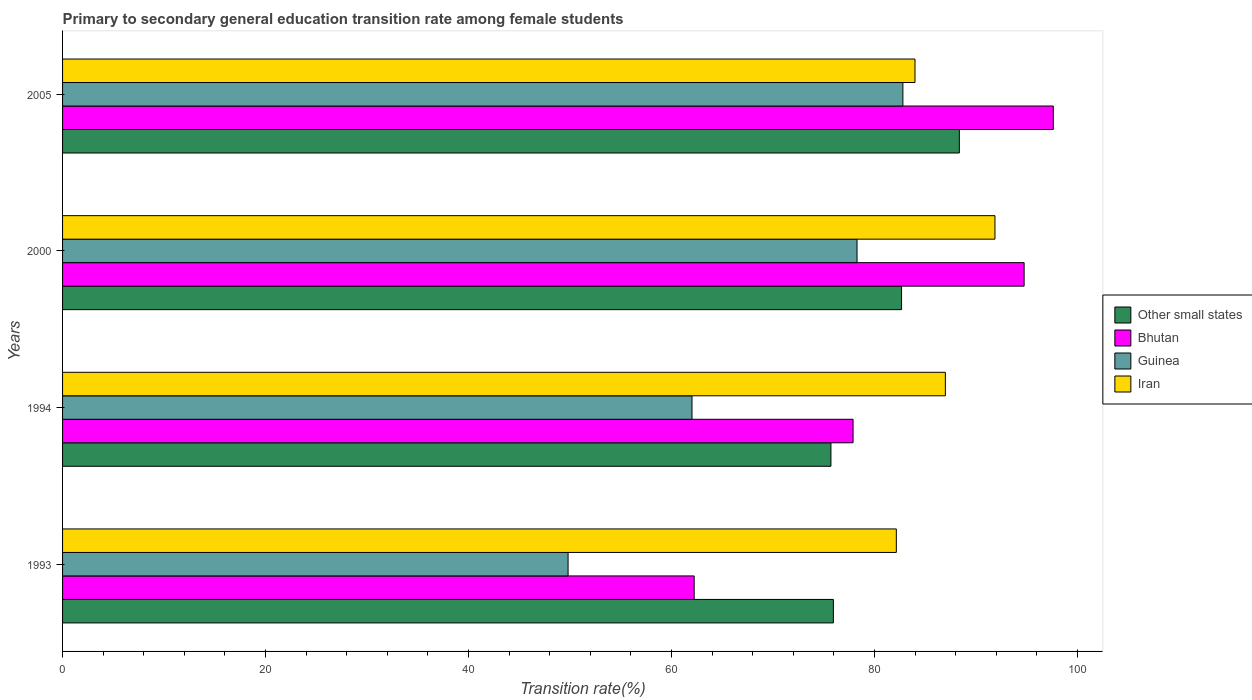How many groups of bars are there?
Ensure brevity in your answer.  4. Are the number of bars per tick equal to the number of legend labels?
Offer a terse response. Yes. How many bars are there on the 3rd tick from the top?
Your answer should be very brief. 4. How many bars are there on the 2nd tick from the bottom?
Your response must be concise. 4. What is the transition rate in Bhutan in 1994?
Provide a succinct answer. 77.89. Across all years, what is the maximum transition rate in Other small states?
Keep it short and to the point. 88.36. Across all years, what is the minimum transition rate in Guinea?
Ensure brevity in your answer.  49.81. In which year was the transition rate in Other small states maximum?
Make the answer very short. 2005. What is the total transition rate in Guinea in the graph?
Offer a terse response. 272.91. What is the difference between the transition rate in Iran in 1994 and that in 2000?
Offer a terse response. -4.89. What is the difference between the transition rate in Guinea in 1994 and the transition rate in Iran in 2005?
Provide a short and direct response. -21.97. What is the average transition rate in Other small states per year?
Offer a very short reply. 80.67. In the year 1994, what is the difference between the transition rate in Other small states and transition rate in Iran?
Keep it short and to the point. -11.28. What is the ratio of the transition rate in Other small states in 1993 to that in 2005?
Offer a very short reply. 0.86. What is the difference between the highest and the second highest transition rate in Iran?
Provide a succinct answer. 4.89. What is the difference between the highest and the lowest transition rate in Guinea?
Keep it short and to the point. 32.99. In how many years, is the transition rate in Other small states greater than the average transition rate in Other small states taken over all years?
Your answer should be very brief. 2. Is the sum of the transition rate in Other small states in 1993 and 2005 greater than the maximum transition rate in Bhutan across all years?
Offer a terse response. Yes. Is it the case that in every year, the sum of the transition rate in Guinea and transition rate in Other small states is greater than the sum of transition rate in Bhutan and transition rate in Iran?
Make the answer very short. No. What does the 2nd bar from the top in 2005 represents?
Your answer should be compact. Guinea. What does the 1st bar from the bottom in 2000 represents?
Your answer should be very brief. Other small states. Is it the case that in every year, the sum of the transition rate in Other small states and transition rate in Guinea is greater than the transition rate in Bhutan?
Your answer should be compact. Yes. Are all the bars in the graph horizontal?
Offer a terse response. Yes. Where does the legend appear in the graph?
Your answer should be very brief. Center right. What is the title of the graph?
Give a very brief answer. Primary to secondary general education transition rate among female students. What is the label or title of the X-axis?
Provide a short and direct response. Transition rate(%). What is the label or title of the Y-axis?
Your response must be concise. Years. What is the Transition rate(%) of Other small states in 1993?
Offer a very short reply. 75.95. What is the Transition rate(%) of Bhutan in 1993?
Provide a short and direct response. 62.23. What is the Transition rate(%) in Guinea in 1993?
Keep it short and to the point. 49.81. What is the Transition rate(%) in Iran in 1993?
Your response must be concise. 82.15. What is the Transition rate(%) of Other small states in 1994?
Keep it short and to the point. 75.71. What is the Transition rate(%) in Bhutan in 1994?
Your response must be concise. 77.89. What is the Transition rate(%) in Guinea in 1994?
Your answer should be very brief. 62.02. What is the Transition rate(%) of Iran in 1994?
Offer a very short reply. 86.98. What is the Transition rate(%) of Other small states in 2000?
Provide a short and direct response. 82.67. What is the Transition rate(%) in Bhutan in 2000?
Your answer should be very brief. 94.74. What is the Transition rate(%) of Guinea in 2000?
Offer a very short reply. 78.28. What is the Transition rate(%) in Iran in 2000?
Give a very brief answer. 91.87. What is the Transition rate(%) of Other small states in 2005?
Your answer should be compact. 88.36. What is the Transition rate(%) of Bhutan in 2005?
Make the answer very short. 97.62. What is the Transition rate(%) in Guinea in 2005?
Ensure brevity in your answer.  82.8. What is the Transition rate(%) in Iran in 2005?
Your answer should be compact. 83.99. Across all years, what is the maximum Transition rate(%) in Other small states?
Keep it short and to the point. 88.36. Across all years, what is the maximum Transition rate(%) in Bhutan?
Give a very brief answer. 97.62. Across all years, what is the maximum Transition rate(%) of Guinea?
Your answer should be very brief. 82.8. Across all years, what is the maximum Transition rate(%) of Iran?
Provide a short and direct response. 91.87. Across all years, what is the minimum Transition rate(%) of Other small states?
Provide a short and direct response. 75.71. Across all years, what is the minimum Transition rate(%) of Bhutan?
Ensure brevity in your answer.  62.23. Across all years, what is the minimum Transition rate(%) of Guinea?
Keep it short and to the point. 49.81. Across all years, what is the minimum Transition rate(%) in Iran?
Your response must be concise. 82.15. What is the total Transition rate(%) in Other small states in the graph?
Your response must be concise. 322.68. What is the total Transition rate(%) of Bhutan in the graph?
Your response must be concise. 332.48. What is the total Transition rate(%) of Guinea in the graph?
Offer a terse response. 272.91. What is the total Transition rate(%) of Iran in the graph?
Your response must be concise. 344.99. What is the difference between the Transition rate(%) of Other small states in 1993 and that in 1994?
Your response must be concise. 0.24. What is the difference between the Transition rate(%) in Bhutan in 1993 and that in 1994?
Your answer should be very brief. -15.66. What is the difference between the Transition rate(%) of Guinea in 1993 and that in 1994?
Your response must be concise. -12.21. What is the difference between the Transition rate(%) in Iran in 1993 and that in 1994?
Ensure brevity in your answer.  -4.83. What is the difference between the Transition rate(%) in Other small states in 1993 and that in 2000?
Provide a succinct answer. -6.72. What is the difference between the Transition rate(%) of Bhutan in 1993 and that in 2000?
Offer a very short reply. -32.51. What is the difference between the Transition rate(%) in Guinea in 1993 and that in 2000?
Make the answer very short. -28.47. What is the difference between the Transition rate(%) in Iran in 1993 and that in 2000?
Offer a terse response. -9.72. What is the difference between the Transition rate(%) in Other small states in 1993 and that in 2005?
Ensure brevity in your answer.  -12.41. What is the difference between the Transition rate(%) in Bhutan in 1993 and that in 2005?
Your answer should be very brief. -35.39. What is the difference between the Transition rate(%) in Guinea in 1993 and that in 2005?
Your response must be concise. -32.99. What is the difference between the Transition rate(%) of Iran in 1993 and that in 2005?
Provide a short and direct response. -1.84. What is the difference between the Transition rate(%) of Other small states in 1994 and that in 2000?
Keep it short and to the point. -6.96. What is the difference between the Transition rate(%) in Bhutan in 1994 and that in 2000?
Make the answer very short. -16.85. What is the difference between the Transition rate(%) of Guinea in 1994 and that in 2000?
Ensure brevity in your answer.  -16.26. What is the difference between the Transition rate(%) in Iran in 1994 and that in 2000?
Your response must be concise. -4.89. What is the difference between the Transition rate(%) in Other small states in 1994 and that in 2005?
Ensure brevity in your answer.  -12.65. What is the difference between the Transition rate(%) in Bhutan in 1994 and that in 2005?
Provide a short and direct response. -19.73. What is the difference between the Transition rate(%) in Guinea in 1994 and that in 2005?
Provide a short and direct response. -20.78. What is the difference between the Transition rate(%) in Iran in 1994 and that in 2005?
Give a very brief answer. 2.99. What is the difference between the Transition rate(%) in Other small states in 2000 and that in 2005?
Your answer should be very brief. -5.69. What is the difference between the Transition rate(%) of Bhutan in 2000 and that in 2005?
Your answer should be very brief. -2.87. What is the difference between the Transition rate(%) of Guinea in 2000 and that in 2005?
Provide a short and direct response. -4.52. What is the difference between the Transition rate(%) of Iran in 2000 and that in 2005?
Make the answer very short. 7.88. What is the difference between the Transition rate(%) of Other small states in 1993 and the Transition rate(%) of Bhutan in 1994?
Provide a succinct answer. -1.94. What is the difference between the Transition rate(%) of Other small states in 1993 and the Transition rate(%) of Guinea in 1994?
Provide a succinct answer. 13.93. What is the difference between the Transition rate(%) of Other small states in 1993 and the Transition rate(%) of Iran in 1994?
Make the answer very short. -11.03. What is the difference between the Transition rate(%) of Bhutan in 1993 and the Transition rate(%) of Guinea in 1994?
Offer a very short reply. 0.21. What is the difference between the Transition rate(%) in Bhutan in 1993 and the Transition rate(%) in Iran in 1994?
Make the answer very short. -24.75. What is the difference between the Transition rate(%) of Guinea in 1993 and the Transition rate(%) of Iran in 1994?
Ensure brevity in your answer.  -37.17. What is the difference between the Transition rate(%) of Other small states in 1993 and the Transition rate(%) of Bhutan in 2000?
Your response must be concise. -18.79. What is the difference between the Transition rate(%) of Other small states in 1993 and the Transition rate(%) of Guinea in 2000?
Make the answer very short. -2.33. What is the difference between the Transition rate(%) in Other small states in 1993 and the Transition rate(%) in Iran in 2000?
Your response must be concise. -15.92. What is the difference between the Transition rate(%) in Bhutan in 1993 and the Transition rate(%) in Guinea in 2000?
Your answer should be very brief. -16.05. What is the difference between the Transition rate(%) of Bhutan in 1993 and the Transition rate(%) of Iran in 2000?
Give a very brief answer. -29.64. What is the difference between the Transition rate(%) of Guinea in 1993 and the Transition rate(%) of Iran in 2000?
Your answer should be very brief. -42.06. What is the difference between the Transition rate(%) in Other small states in 1993 and the Transition rate(%) in Bhutan in 2005?
Your answer should be compact. -21.67. What is the difference between the Transition rate(%) in Other small states in 1993 and the Transition rate(%) in Guinea in 2005?
Offer a terse response. -6.85. What is the difference between the Transition rate(%) of Other small states in 1993 and the Transition rate(%) of Iran in 2005?
Provide a short and direct response. -8.04. What is the difference between the Transition rate(%) of Bhutan in 1993 and the Transition rate(%) of Guinea in 2005?
Give a very brief answer. -20.57. What is the difference between the Transition rate(%) of Bhutan in 1993 and the Transition rate(%) of Iran in 2005?
Your response must be concise. -21.76. What is the difference between the Transition rate(%) in Guinea in 1993 and the Transition rate(%) in Iran in 2005?
Your answer should be very brief. -34.18. What is the difference between the Transition rate(%) in Other small states in 1994 and the Transition rate(%) in Bhutan in 2000?
Your answer should be very brief. -19.04. What is the difference between the Transition rate(%) in Other small states in 1994 and the Transition rate(%) in Guinea in 2000?
Your answer should be very brief. -2.57. What is the difference between the Transition rate(%) of Other small states in 1994 and the Transition rate(%) of Iran in 2000?
Give a very brief answer. -16.16. What is the difference between the Transition rate(%) of Bhutan in 1994 and the Transition rate(%) of Guinea in 2000?
Your answer should be compact. -0.39. What is the difference between the Transition rate(%) of Bhutan in 1994 and the Transition rate(%) of Iran in 2000?
Offer a very short reply. -13.98. What is the difference between the Transition rate(%) in Guinea in 1994 and the Transition rate(%) in Iran in 2000?
Your response must be concise. -29.85. What is the difference between the Transition rate(%) in Other small states in 1994 and the Transition rate(%) in Bhutan in 2005?
Give a very brief answer. -21.91. What is the difference between the Transition rate(%) in Other small states in 1994 and the Transition rate(%) in Guinea in 2005?
Offer a very short reply. -7.09. What is the difference between the Transition rate(%) of Other small states in 1994 and the Transition rate(%) of Iran in 2005?
Your response must be concise. -8.28. What is the difference between the Transition rate(%) of Bhutan in 1994 and the Transition rate(%) of Guinea in 2005?
Offer a very short reply. -4.91. What is the difference between the Transition rate(%) of Bhutan in 1994 and the Transition rate(%) of Iran in 2005?
Your response must be concise. -6.1. What is the difference between the Transition rate(%) of Guinea in 1994 and the Transition rate(%) of Iran in 2005?
Keep it short and to the point. -21.97. What is the difference between the Transition rate(%) in Other small states in 2000 and the Transition rate(%) in Bhutan in 2005?
Give a very brief answer. -14.95. What is the difference between the Transition rate(%) in Other small states in 2000 and the Transition rate(%) in Guinea in 2005?
Your answer should be very brief. -0.13. What is the difference between the Transition rate(%) in Other small states in 2000 and the Transition rate(%) in Iran in 2005?
Your answer should be compact. -1.32. What is the difference between the Transition rate(%) in Bhutan in 2000 and the Transition rate(%) in Guinea in 2005?
Make the answer very short. 11.94. What is the difference between the Transition rate(%) in Bhutan in 2000 and the Transition rate(%) in Iran in 2005?
Ensure brevity in your answer.  10.75. What is the difference between the Transition rate(%) in Guinea in 2000 and the Transition rate(%) in Iran in 2005?
Your answer should be compact. -5.71. What is the average Transition rate(%) in Other small states per year?
Offer a very short reply. 80.67. What is the average Transition rate(%) in Bhutan per year?
Ensure brevity in your answer.  83.12. What is the average Transition rate(%) in Guinea per year?
Provide a short and direct response. 68.23. What is the average Transition rate(%) of Iran per year?
Your answer should be very brief. 86.25. In the year 1993, what is the difference between the Transition rate(%) in Other small states and Transition rate(%) in Bhutan?
Offer a terse response. 13.72. In the year 1993, what is the difference between the Transition rate(%) of Other small states and Transition rate(%) of Guinea?
Give a very brief answer. 26.14. In the year 1993, what is the difference between the Transition rate(%) in Other small states and Transition rate(%) in Iran?
Provide a succinct answer. -6.2. In the year 1993, what is the difference between the Transition rate(%) in Bhutan and Transition rate(%) in Guinea?
Provide a short and direct response. 12.42. In the year 1993, what is the difference between the Transition rate(%) of Bhutan and Transition rate(%) of Iran?
Provide a succinct answer. -19.92. In the year 1993, what is the difference between the Transition rate(%) of Guinea and Transition rate(%) of Iran?
Provide a succinct answer. -32.34. In the year 1994, what is the difference between the Transition rate(%) in Other small states and Transition rate(%) in Bhutan?
Your answer should be very brief. -2.18. In the year 1994, what is the difference between the Transition rate(%) of Other small states and Transition rate(%) of Guinea?
Offer a very short reply. 13.69. In the year 1994, what is the difference between the Transition rate(%) of Other small states and Transition rate(%) of Iran?
Give a very brief answer. -11.28. In the year 1994, what is the difference between the Transition rate(%) of Bhutan and Transition rate(%) of Guinea?
Offer a very short reply. 15.87. In the year 1994, what is the difference between the Transition rate(%) of Bhutan and Transition rate(%) of Iran?
Your answer should be very brief. -9.09. In the year 1994, what is the difference between the Transition rate(%) in Guinea and Transition rate(%) in Iran?
Your response must be concise. -24.96. In the year 2000, what is the difference between the Transition rate(%) in Other small states and Transition rate(%) in Bhutan?
Your answer should be compact. -12.08. In the year 2000, what is the difference between the Transition rate(%) in Other small states and Transition rate(%) in Guinea?
Your response must be concise. 4.39. In the year 2000, what is the difference between the Transition rate(%) in Other small states and Transition rate(%) in Iran?
Make the answer very short. -9.2. In the year 2000, what is the difference between the Transition rate(%) in Bhutan and Transition rate(%) in Guinea?
Give a very brief answer. 16.46. In the year 2000, what is the difference between the Transition rate(%) in Bhutan and Transition rate(%) in Iran?
Your response must be concise. 2.87. In the year 2000, what is the difference between the Transition rate(%) in Guinea and Transition rate(%) in Iran?
Offer a terse response. -13.59. In the year 2005, what is the difference between the Transition rate(%) of Other small states and Transition rate(%) of Bhutan?
Offer a very short reply. -9.26. In the year 2005, what is the difference between the Transition rate(%) in Other small states and Transition rate(%) in Guinea?
Offer a very short reply. 5.56. In the year 2005, what is the difference between the Transition rate(%) of Other small states and Transition rate(%) of Iran?
Give a very brief answer. 4.37. In the year 2005, what is the difference between the Transition rate(%) in Bhutan and Transition rate(%) in Guinea?
Provide a succinct answer. 14.82. In the year 2005, what is the difference between the Transition rate(%) in Bhutan and Transition rate(%) in Iran?
Make the answer very short. 13.63. In the year 2005, what is the difference between the Transition rate(%) of Guinea and Transition rate(%) of Iran?
Offer a very short reply. -1.19. What is the ratio of the Transition rate(%) of Other small states in 1993 to that in 1994?
Offer a terse response. 1. What is the ratio of the Transition rate(%) of Bhutan in 1993 to that in 1994?
Offer a terse response. 0.8. What is the ratio of the Transition rate(%) of Guinea in 1993 to that in 1994?
Give a very brief answer. 0.8. What is the ratio of the Transition rate(%) in Iran in 1993 to that in 1994?
Your answer should be very brief. 0.94. What is the ratio of the Transition rate(%) in Other small states in 1993 to that in 2000?
Your response must be concise. 0.92. What is the ratio of the Transition rate(%) in Bhutan in 1993 to that in 2000?
Offer a terse response. 0.66. What is the ratio of the Transition rate(%) in Guinea in 1993 to that in 2000?
Keep it short and to the point. 0.64. What is the ratio of the Transition rate(%) in Iran in 1993 to that in 2000?
Make the answer very short. 0.89. What is the ratio of the Transition rate(%) of Other small states in 1993 to that in 2005?
Make the answer very short. 0.86. What is the ratio of the Transition rate(%) of Bhutan in 1993 to that in 2005?
Your answer should be very brief. 0.64. What is the ratio of the Transition rate(%) in Guinea in 1993 to that in 2005?
Keep it short and to the point. 0.6. What is the ratio of the Transition rate(%) in Iran in 1993 to that in 2005?
Ensure brevity in your answer.  0.98. What is the ratio of the Transition rate(%) in Other small states in 1994 to that in 2000?
Your answer should be very brief. 0.92. What is the ratio of the Transition rate(%) of Bhutan in 1994 to that in 2000?
Provide a short and direct response. 0.82. What is the ratio of the Transition rate(%) in Guinea in 1994 to that in 2000?
Provide a short and direct response. 0.79. What is the ratio of the Transition rate(%) in Iran in 1994 to that in 2000?
Your answer should be very brief. 0.95. What is the ratio of the Transition rate(%) of Other small states in 1994 to that in 2005?
Your answer should be compact. 0.86. What is the ratio of the Transition rate(%) in Bhutan in 1994 to that in 2005?
Provide a short and direct response. 0.8. What is the ratio of the Transition rate(%) of Guinea in 1994 to that in 2005?
Provide a short and direct response. 0.75. What is the ratio of the Transition rate(%) of Iran in 1994 to that in 2005?
Offer a terse response. 1.04. What is the ratio of the Transition rate(%) of Other small states in 2000 to that in 2005?
Offer a very short reply. 0.94. What is the ratio of the Transition rate(%) of Bhutan in 2000 to that in 2005?
Provide a short and direct response. 0.97. What is the ratio of the Transition rate(%) of Guinea in 2000 to that in 2005?
Keep it short and to the point. 0.95. What is the ratio of the Transition rate(%) of Iran in 2000 to that in 2005?
Keep it short and to the point. 1.09. What is the difference between the highest and the second highest Transition rate(%) of Other small states?
Your response must be concise. 5.69. What is the difference between the highest and the second highest Transition rate(%) in Bhutan?
Give a very brief answer. 2.87. What is the difference between the highest and the second highest Transition rate(%) of Guinea?
Provide a succinct answer. 4.52. What is the difference between the highest and the second highest Transition rate(%) of Iran?
Offer a terse response. 4.89. What is the difference between the highest and the lowest Transition rate(%) of Other small states?
Make the answer very short. 12.65. What is the difference between the highest and the lowest Transition rate(%) in Bhutan?
Make the answer very short. 35.39. What is the difference between the highest and the lowest Transition rate(%) in Guinea?
Offer a very short reply. 32.99. What is the difference between the highest and the lowest Transition rate(%) in Iran?
Give a very brief answer. 9.72. 